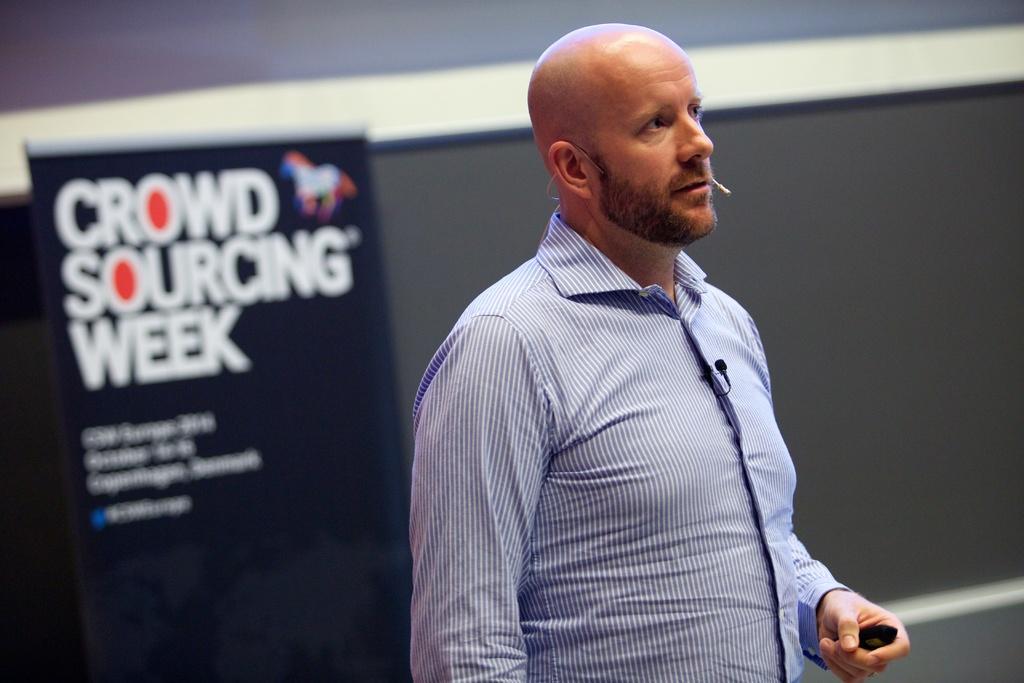Can you describe this image briefly? In this image we can see a person standing and holding an object. There is an advertising banner at the left side of the image. There is a wall in the image. 